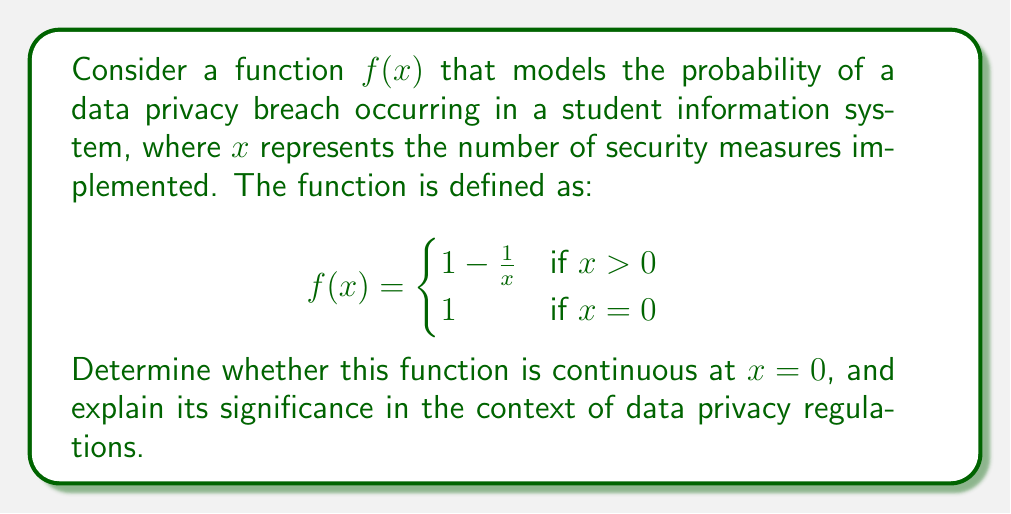Give your solution to this math problem. To determine if the function $f(x)$ is continuous at $x = 0$, we need to check if the following three conditions are met:

1. $f(0)$ exists
2. $\lim_{x \to 0^+} f(x)$ exists
3. $f(0) = \lim_{x \to 0^+} f(x)$

Let's examine each condition:

1. $f(0)$ exists:
   From the given piecewise function, we can see that $f(0) = 1$.

2. $\lim_{x \to 0^+} f(x)$ exists:
   We need to evaluate the limit as $x$ approaches 0 from the right side.
   
   $\lim_{x \to 0^+} f(x) = \lim_{x \to 0^+} (1 - \frac{1}{x})$
   
   As $x$ approaches 0 from the right, $\frac{1}{x}$ grows infinitely large.
   Therefore, $\lim_{x \to 0^+} (1 - \frac{1}{x}) = 1 - (+\infty) = -\infty$

3. Comparing $f(0)$ and $\lim_{x \to 0^+} f(x)$:
   $f(0) = 1$, but $\lim_{x \to 0^+} f(x) = -\infty$

Since $f(0) \neq \lim_{x \to 0^+} f(x)$, the function is not continuous at $x = 0$.

Significance in the context of data privacy regulations:

This discontinuity at $x = 0$ represents a critical point in data privacy protection. When no security measures are implemented $(x = 0)$, the probability of a data breach is 1 (certainty). However, as soon as any security measure is implemented $(x > 0)$, the probability of a breach drops significantly. This abrupt change highlights the importance of having at least some basic security measures in place.

For policymakers, this model suggests that regulations should require a minimum set of security measures for all student information systems, as even a small number of measures can dramatically reduce the risk of data breaches. The continuous decrease in breach probability as more measures are added $(x > 0)$ also supports the idea of encouraging or requiring multiple layers of security in data protection policies.
Answer: The function $f(x)$ is not continuous at $x = 0$ because $f(0) = 1$, but $\lim_{x \to 0^+} f(x) = -\infty$. This discontinuity emphasizes the critical importance of implementing at least some basic security measures in student data systems. 